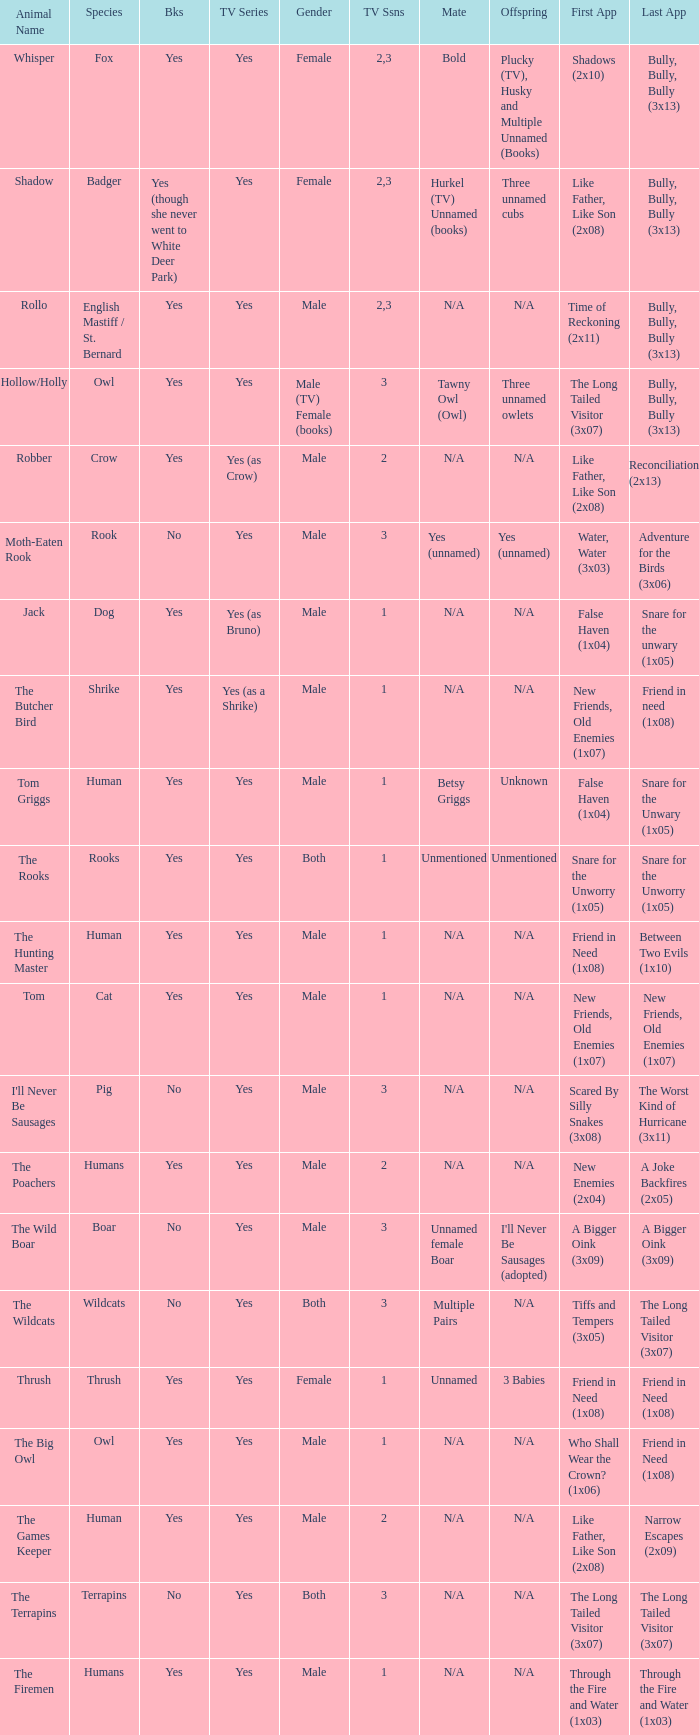What is the mate for Last Appearance of bully, bully, bully (3x13) for the animal named hollow/holly later than season 1? Tawny Owl (Owl). 